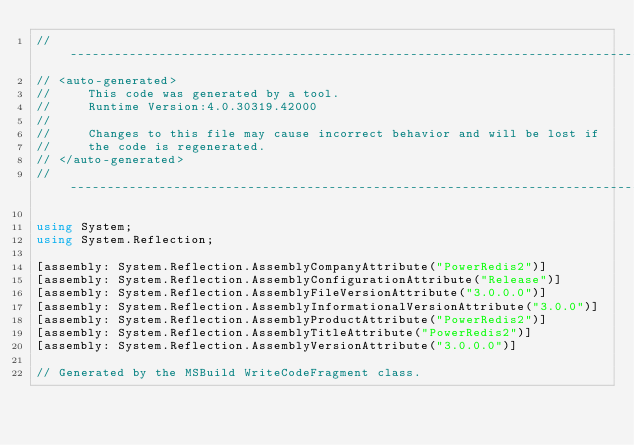<code> <loc_0><loc_0><loc_500><loc_500><_C#_>//------------------------------------------------------------------------------
// <auto-generated>
//     This code was generated by a tool.
//     Runtime Version:4.0.30319.42000
//
//     Changes to this file may cause incorrect behavior and will be lost if
//     the code is regenerated.
// </auto-generated>
//------------------------------------------------------------------------------

using System;
using System.Reflection;

[assembly: System.Reflection.AssemblyCompanyAttribute("PowerRedis2")]
[assembly: System.Reflection.AssemblyConfigurationAttribute("Release")]
[assembly: System.Reflection.AssemblyFileVersionAttribute("3.0.0.0")]
[assembly: System.Reflection.AssemblyInformationalVersionAttribute("3.0.0")]
[assembly: System.Reflection.AssemblyProductAttribute("PowerRedis2")]
[assembly: System.Reflection.AssemblyTitleAttribute("PowerRedis2")]
[assembly: System.Reflection.AssemblyVersionAttribute("3.0.0.0")]

// Generated by the MSBuild WriteCodeFragment class.

</code> 